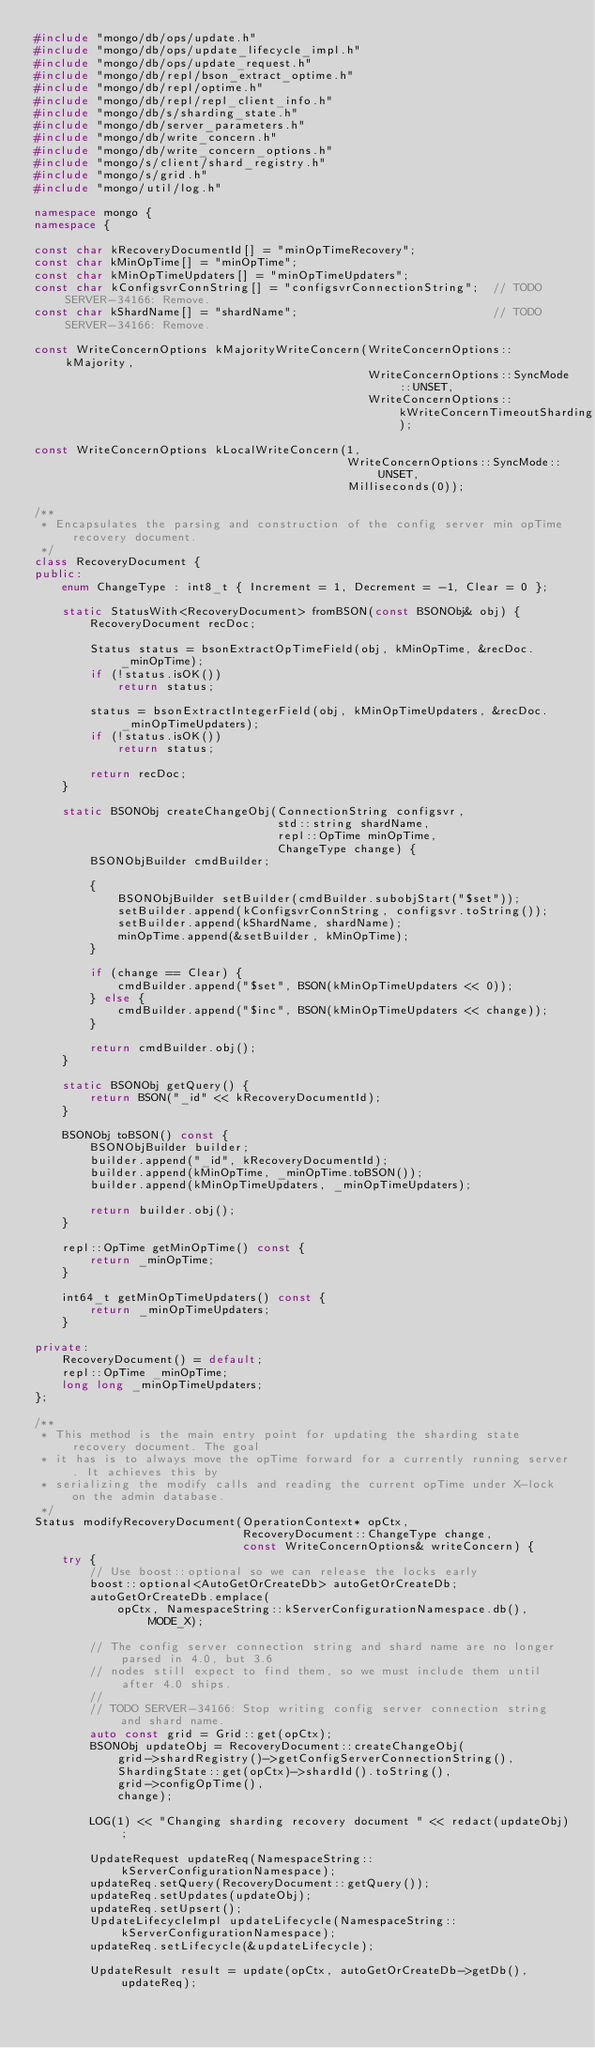Convert code to text. <code><loc_0><loc_0><loc_500><loc_500><_C++_>#include "mongo/db/ops/update.h"
#include "mongo/db/ops/update_lifecycle_impl.h"
#include "mongo/db/ops/update_request.h"
#include "mongo/db/repl/bson_extract_optime.h"
#include "mongo/db/repl/optime.h"
#include "mongo/db/repl/repl_client_info.h"
#include "mongo/db/s/sharding_state.h"
#include "mongo/db/server_parameters.h"
#include "mongo/db/write_concern.h"
#include "mongo/db/write_concern_options.h"
#include "mongo/s/client/shard_registry.h"
#include "mongo/s/grid.h"
#include "mongo/util/log.h"

namespace mongo {
namespace {

const char kRecoveryDocumentId[] = "minOpTimeRecovery";
const char kMinOpTime[] = "minOpTime";
const char kMinOpTimeUpdaters[] = "minOpTimeUpdaters";
const char kConfigsvrConnString[] = "configsvrConnectionString";  // TODO SERVER-34166: Remove.
const char kShardName[] = "shardName";                            // TODO SERVER-34166: Remove.

const WriteConcernOptions kMajorityWriteConcern(WriteConcernOptions::kMajority,
                                                WriteConcernOptions::SyncMode::UNSET,
                                                WriteConcernOptions::kWriteConcernTimeoutSharding);

const WriteConcernOptions kLocalWriteConcern(1,
                                             WriteConcernOptions::SyncMode::UNSET,
                                             Milliseconds(0));

/**
 * Encapsulates the parsing and construction of the config server min opTime recovery document.
 */
class RecoveryDocument {
public:
    enum ChangeType : int8_t { Increment = 1, Decrement = -1, Clear = 0 };

    static StatusWith<RecoveryDocument> fromBSON(const BSONObj& obj) {
        RecoveryDocument recDoc;

        Status status = bsonExtractOpTimeField(obj, kMinOpTime, &recDoc._minOpTime);
        if (!status.isOK())
            return status;

        status = bsonExtractIntegerField(obj, kMinOpTimeUpdaters, &recDoc._minOpTimeUpdaters);
        if (!status.isOK())
            return status;

        return recDoc;
    }

    static BSONObj createChangeObj(ConnectionString configsvr,
                                   std::string shardName,
                                   repl::OpTime minOpTime,
                                   ChangeType change) {
        BSONObjBuilder cmdBuilder;

        {
            BSONObjBuilder setBuilder(cmdBuilder.subobjStart("$set"));
            setBuilder.append(kConfigsvrConnString, configsvr.toString());
            setBuilder.append(kShardName, shardName);
            minOpTime.append(&setBuilder, kMinOpTime);
        }

        if (change == Clear) {
            cmdBuilder.append("$set", BSON(kMinOpTimeUpdaters << 0));
        } else {
            cmdBuilder.append("$inc", BSON(kMinOpTimeUpdaters << change));
        }

        return cmdBuilder.obj();
    }

    static BSONObj getQuery() {
        return BSON("_id" << kRecoveryDocumentId);
    }

    BSONObj toBSON() const {
        BSONObjBuilder builder;
        builder.append("_id", kRecoveryDocumentId);
        builder.append(kMinOpTime, _minOpTime.toBSON());
        builder.append(kMinOpTimeUpdaters, _minOpTimeUpdaters);

        return builder.obj();
    }

    repl::OpTime getMinOpTime() const {
        return _minOpTime;
    }

    int64_t getMinOpTimeUpdaters() const {
        return _minOpTimeUpdaters;
    }

private:
    RecoveryDocument() = default;
    repl::OpTime _minOpTime;
    long long _minOpTimeUpdaters;
};

/**
 * This method is the main entry point for updating the sharding state recovery document. The goal
 * it has is to always move the opTime forward for a currently running server. It achieves this by
 * serializing the modify calls and reading the current opTime under X-lock on the admin database.
 */
Status modifyRecoveryDocument(OperationContext* opCtx,
                              RecoveryDocument::ChangeType change,
                              const WriteConcernOptions& writeConcern) {
    try {
        // Use boost::optional so we can release the locks early
        boost::optional<AutoGetOrCreateDb> autoGetOrCreateDb;
        autoGetOrCreateDb.emplace(
            opCtx, NamespaceString::kServerConfigurationNamespace.db(), MODE_X);

        // The config server connection string and shard name are no longer parsed in 4.0, but 3.6
        // nodes still expect to find them, so we must include them until after 4.0 ships.
        //
        // TODO SERVER-34166: Stop writing config server connection string and shard name.
        auto const grid = Grid::get(opCtx);
        BSONObj updateObj = RecoveryDocument::createChangeObj(
            grid->shardRegistry()->getConfigServerConnectionString(),
            ShardingState::get(opCtx)->shardId().toString(),
            grid->configOpTime(),
            change);

        LOG(1) << "Changing sharding recovery document " << redact(updateObj);

        UpdateRequest updateReq(NamespaceString::kServerConfigurationNamespace);
        updateReq.setQuery(RecoveryDocument::getQuery());
        updateReq.setUpdates(updateObj);
        updateReq.setUpsert();
        UpdateLifecycleImpl updateLifecycle(NamespaceString::kServerConfigurationNamespace);
        updateReq.setLifecycle(&updateLifecycle);

        UpdateResult result = update(opCtx, autoGetOrCreateDb->getDb(), updateReq);</code> 